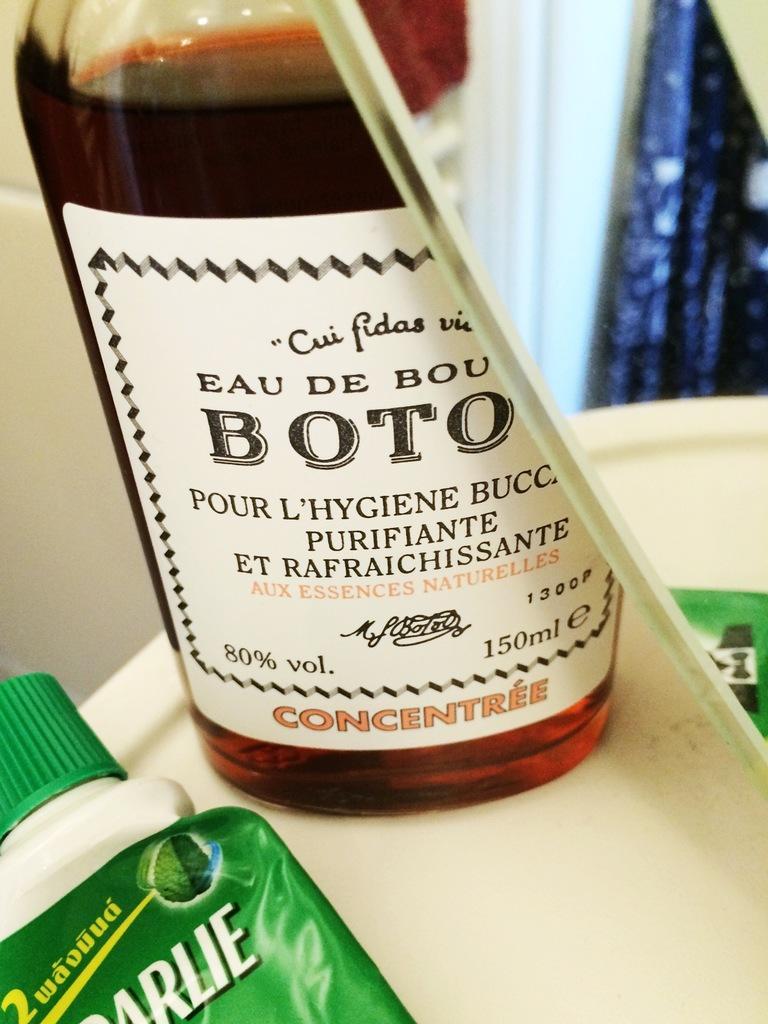Please provide a concise description of this image. There is a bottle having sticker pasted on it and is filled with drink on the white color table near a mirror and a bottle. And the background is white in color. 